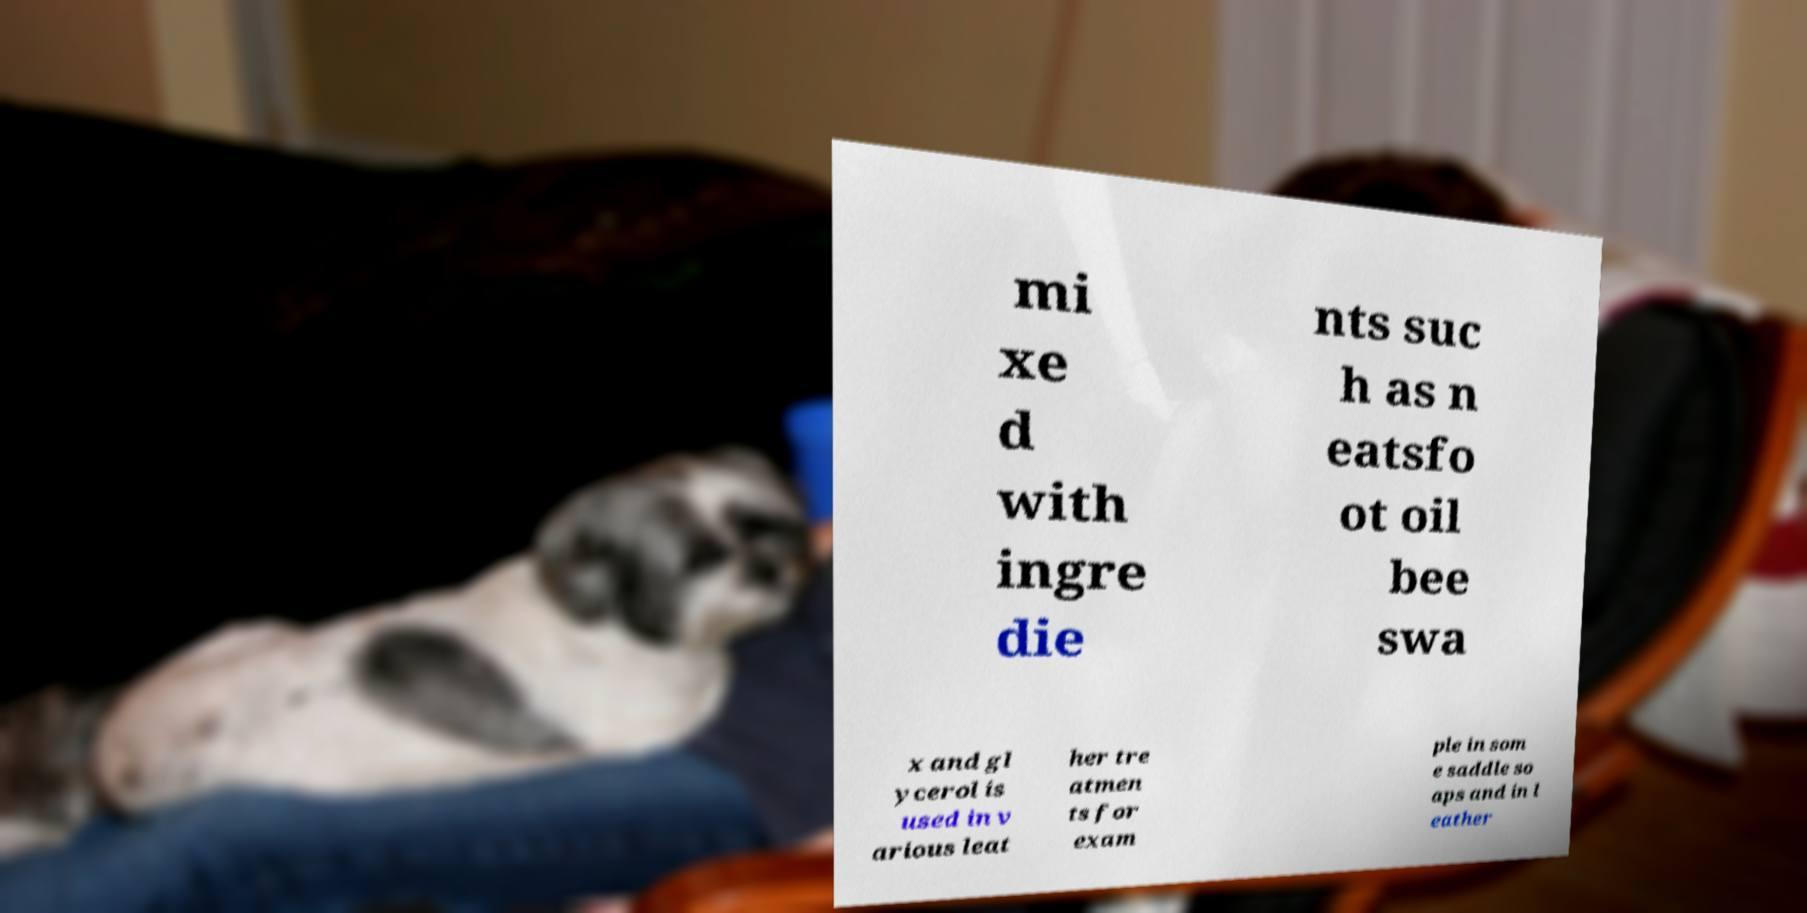Please identify and transcribe the text found in this image. mi xe d with ingre die nts suc h as n eatsfo ot oil bee swa x and gl ycerol is used in v arious leat her tre atmen ts for exam ple in som e saddle so aps and in l eather 